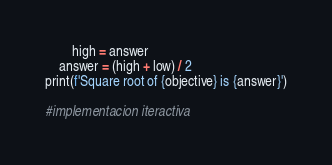Convert code to text. <code><loc_0><loc_0><loc_500><loc_500><_Python_>        high = answer
    answer = (high + low) / 2
print(f'Square root of {objective} is {answer}')

#implementacion iteractiva</code> 